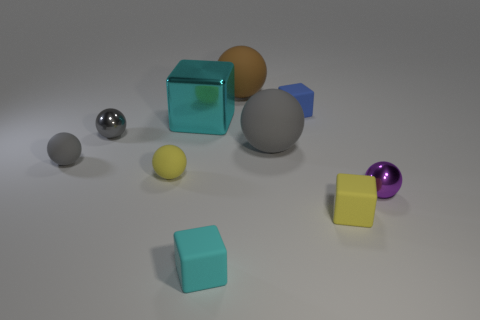There is a yellow object that is the same shape as the tiny gray metallic object; what is its size?
Give a very brief answer. Small. How many tiny purple balls are made of the same material as the yellow block?
Offer a terse response. 0. Is the material of the yellow thing that is to the right of the brown thing the same as the small cyan cube?
Keep it short and to the point. Yes. Is the number of yellow cubes to the left of the large brown rubber object the same as the number of brown matte spheres?
Offer a terse response. No. What size is the purple object?
Offer a very short reply. Small. There is a object that is the same color as the metallic cube; what is its material?
Make the answer very short. Rubber. What number of rubber objects are the same color as the metal cube?
Your answer should be very brief. 1. Does the yellow block have the same size as the cyan metallic object?
Your answer should be very brief. No. How big is the gray thing that is to the right of the cyan thing left of the small cyan thing?
Provide a short and direct response. Large. Does the large cube have the same color as the shiny sphere behind the small purple metal object?
Your response must be concise. No. 